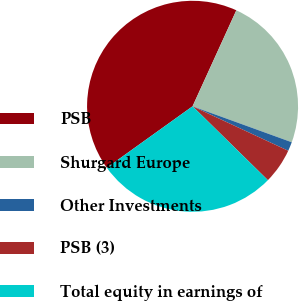<chart> <loc_0><loc_0><loc_500><loc_500><pie_chart><fcel>PSB<fcel>Shurgard Europe<fcel>Other Investments<fcel>PSB (3)<fcel>Total equity in earnings of<nl><fcel>41.71%<fcel>23.73%<fcel>1.39%<fcel>5.42%<fcel>27.76%<nl></chart> 